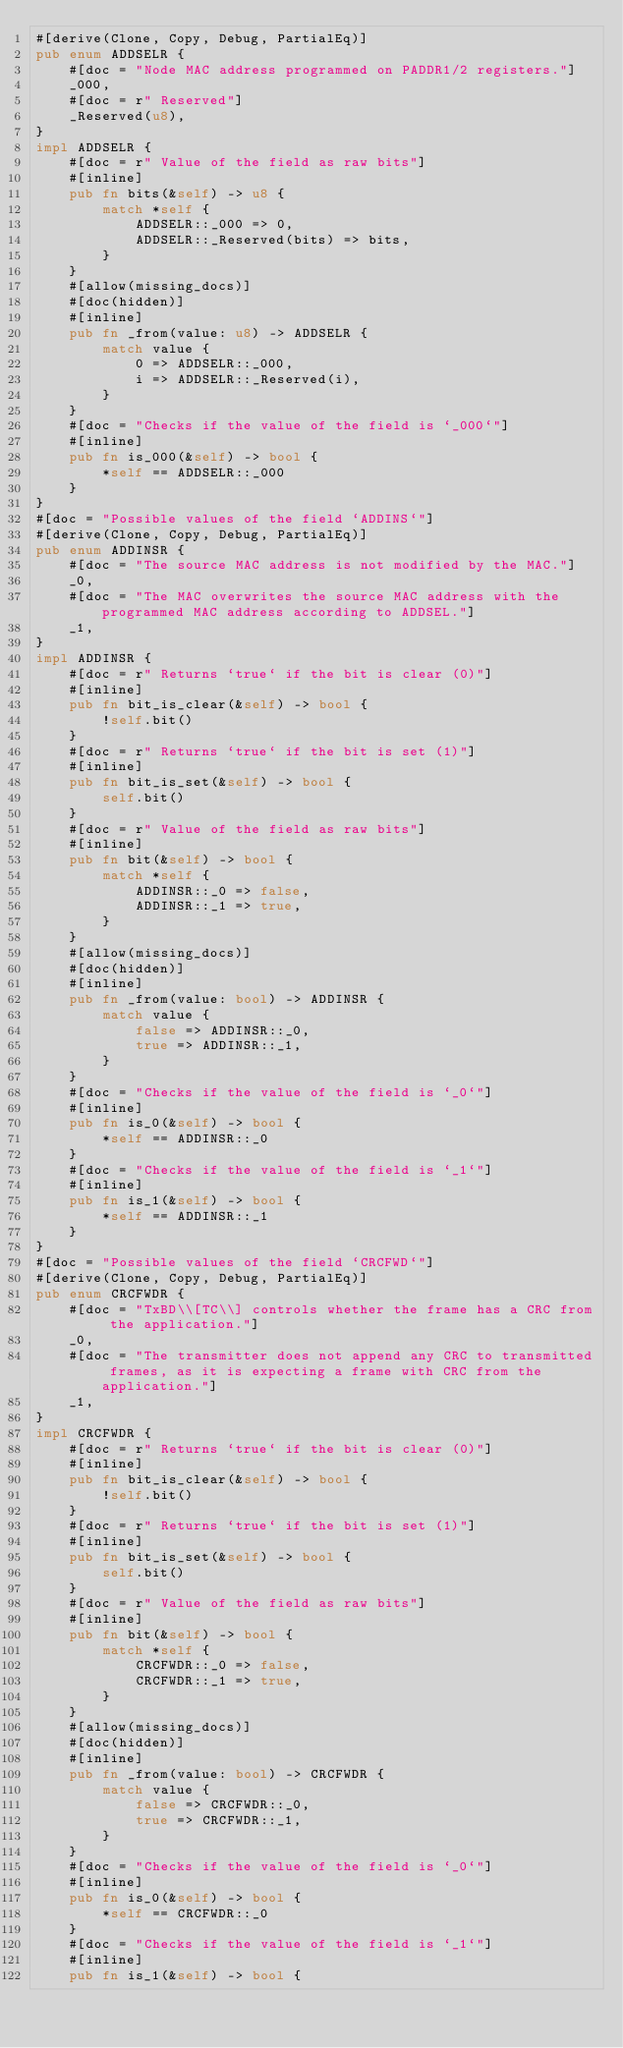<code> <loc_0><loc_0><loc_500><loc_500><_Rust_>#[derive(Clone, Copy, Debug, PartialEq)]
pub enum ADDSELR {
    #[doc = "Node MAC address programmed on PADDR1/2 registers."]
    _000,
    #[doc = r" Reserved"]
    _Reserved(u8),
}
impl ADDSELR {
    #[doc = r" Value of the field as raw bits"]
    #[inline]
    pub fn bits(&self) -> u8 {
        match *self {
            ADDSELR::_000 => 0,
            ADDSELR::_Reserved(bits) => bits,
        }
    }
    #[allow(missing_docs)]
    #[doc(hidden)]
    #[inline]
    pub fn _from(value: u8) -> ADDSELR {
        match value {
            0 => ADDSELR::_000,
            i => ADDSELR::_Reserved(i),
        }
    }
    #[doc = "Checks if the value of the field is `_000`"]
    #[inline]
    pub fn is_000(&self) -> bool {
        *self == ADDSELR::_000
    }
}
#[doc = "Possible values of the field `ADDINS`"]
#[derive(Clone, Copy, Debug, PartialEq)]
pub enum ADDINSR {
    #[doc = "The source MAC address is not modified by the MAC."]
    _0,
    #[doc = "The MAC overwrites the source MAC address with the programmed MAC address according to ADDSEL."]
    _1,
}
impl ADDINSR {
    #[doc = r" Returns `true` if the bit is clear (0)"]
    #[inline]
    pub fn bit_is_clear(&self) -> bool {
        !self.bit()
    }
    #[doc = r" Returns `true` if the bit is set (1)"]
    #[inline]
    pub fn bit_is_set(&self) -> bool {
        self.bit()
    }
    #[doc = r" Value of the field as raw bits"]
    #[inline]
    pub fn bit(&self) -> bool {
        match *self {
            ADDINSR::_0 => false,
            ADDINSR::_1 => true,
        }
    }
    #[allow(missing_docs)]
    #[doc(hidden)]
    #[inline]
    pub fn _from(value: bool) -> ADDINSR {
        match value {
            false => ADDINSR::_0,
            true => ADDINSR::_1,
        }
    }
    #[doc = "Checks if the value of the field is `_0`"]
    #[inline]
    pub fn is_0(&self) -> bool {
        *self == ADDINSR::_0
    }
    #[doc = "Checks if the value of the field is `_1`"]
    #[inline]
    pub fn is_1(&self) -> bool {
        *self == ADDINSR::_1
    }
}
#[doc = "Possible values of the field `CRCFWD`"]
#[derive(Clone, Copy, Debug, PartialEq)]
pub enum CRCFWDR {
    #[doc = "TxBD\\[TC\\] controls whether the frame has a CRC from the application."]
    _0,
    #[doc = "The transmitter does not append any CRC to transmitted frames, as it is expecting a frame with CRC from the application."]
    _1,
}
impl CRCFWDR {
    #[doc = r" Returns `true` if the bit is clear (0)"]
    #[inline]
    pub fn bit_is_clear(&self) -> bool {
        !self.bit()
    }
    #[doc = r" Returns `true` if the bit is set (1)"]
    #[inline]
    pub fn bit_is_set(&self) -> bool {
        self.bit()
    }
    #[doc = r" Value of the field as raw bits"]
    #[inline]
    pub fn bit(&self) -> bool {
        match *self {
            CRCFWDR::_0 => false,
            CRCFWDR::_1 => true,
        }
    }
    #[allow(missing_docs)]
    #[doc(hidden)]
    #[inline]
    pub fn _from(value: bool) -> CRCFWDR {
        match value {
            false => CRCFWDR::_0,
            true => CRCFWDR::_1,
        }
    }
    #[doc = "Checks if the value of the field is `_0`"]
    #[inline]
    pub fn is_0(&self) -> bool {
        *self == CRCFWDR::_0
    }
    #[doc = "Checks if the value of the field is `_1`"]
    #[inline]
    pub fn is_1(&self) -> bool {</code> 